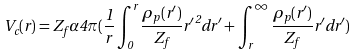Convert formula to latex. <formula><loc_0><loc_0><loc_500><loc_500>V _ { c } ( r ) = Z _ { f } \alpha 4 \pi ( \frac { 1 } { r } \int _ { 0 } ^ { r } \frac { \rho _ { p } ( r ^ { \prime } ) } { Z _ { f } } { r ^ { \prime } } ^ { 2 } d r ^ { \prime } + \int _ { r } ^ { \infty } \frac { \rho _ { p } ( r ^ { \prime } ) } { Z _ { f } } { r ^ { \prime } } d r ^ { \prime } )</formula> 